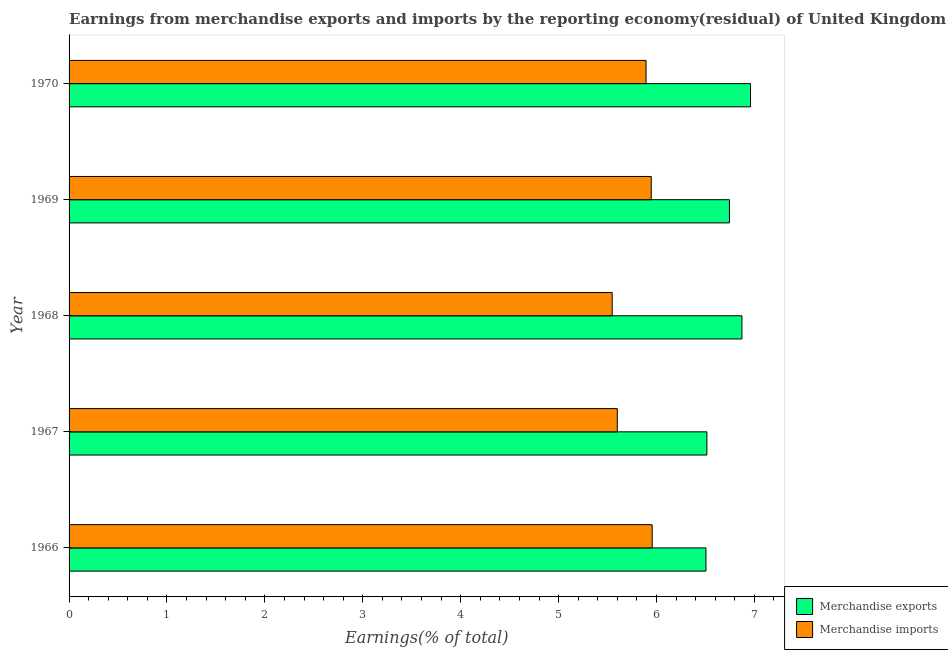Are the number of bars per tick equal to the number of legend labels?
Provide a short and direct response. Yes. How many bars are there on the 3rd tick from the top?
Offer a very short reply. 2. What is the label of the 3rd group of bars from the top?
Make the answer very short. 1968. In how many cases, is the number of bars for a given year not equal to the number of legend labels?
Ensure brevity in your answer.  0. What is the earnings from merchandise imports in 1970?
Provide a succinct answer. 5.89. Across all years, what is the maximum earnings from merchandise exports?
Provide a succinct answer. 6.96. Across all years, what is the minimum earnings from merchandise exports?
Your answer should be compact. 6.51. In which year was the earnings from merchandise imports maximum?
Your answer should be very brief. 1966. In which year was the earnings from merchandise imports minimum?
Offer a very short reply. 1968. What is the total earnings from merchandise imports in the graph?
Give a very brief answer. 28.94. What is the difference between the earnings from merchandise exports in 1966 and that in 1969?
Your response must be concise. -0.24. What is the difference between the earnings from merchandise imports in 1966 and the earnings from merchandise exports in 1967?
Your answer should be compact. -0.56. What is the average earnings from merchandise imports per year?
Your answer should be very brief. 5.79. In the year 1970, what is the difference between the earnings from merchandise imports and earnings from merchandise exports?
Provide a succinct answer. -1.07. What is the difference between the highest and the second highest earnings from merchandise exports?
Provide a short and direct response. 0.09. What is the difference between the highest and the lowest earnings from merchandise imports?
Offer a very short reply. 0.41. Is the sum of the earnings from merchandise imports in 1966 and 1967 greater than the maximum earnings from merchandise exports across all years?
Provide a succinct answer. Yes. What does the 1st bar from the bottom in 1968 represents?
Give a very brief answer. Merchandise exports. How many years are there in the graph?
Give a very brief answer. 5. What is the difference between two consecutive major ticks on the X-axis?
Provide a short and direct response. 1. Are the values on the major ticks of X-axis written in scientific E-notation?
Your response must be concise. No. Where does the legend appear in the graph?
Your answer should be compact. Bottom right. What is the title of the graph?
Provide a short and direct response. Earnings from merchandise exports and imports by the reporting economy(residual) of United Kingdom. What is the label or title of the X-axis?
Provide a succinct answer. Earnings(% of total). What is the label or title of the Y-axis?
Make the answer very short. Year. What is the Earnings(% of total) of Merchandise exports in 1966?
Your response must be concise. 6.51. What is the Earnings(% of total) of Merchandise imports in 1966?
Make the answer very short. 5.96. What is the Earnings(% of total) in Merchandise exports in 1967?
Keep it short and to the point. 6.51. What is the Earnings(% of total) in Merchandise imports in 1967?
Offer a terse response. 5.6. What is the Earnings(% of total) in Merchandise exports in 1968?
Offer a terse response. 6.87. What is the Earnings(% of total) in Merchandise imports in 1968?
Provide a short and direct response. 5.55. What is the Earnings(% of total) in Merchandise exports in 1969?
Offer a terse response. 6.75. What is the Earnings(% of total) in Merchandise imports in 1969?
Give a very brief answer. 5.95. What is the Earnings(% of total) of Merchandise exports in 1970?
Offer a very short reply. 6.96. What is the Earnings(% of total) of Merchandise imports in 1970?
Your response must be concise. 5.89. Across all years, what is the maximum Earnings(% of total) of Merchandise exports?
Ensure brevity in your answer.  6.96. Across all years, what is the maximum Earnings(% of total) in Merchandise imports?
Offer a very short reply. 5.96. Across all years, what is the minimum Earnings(% of total) of Merchandise exports?
Your answer should be very brief. 6.51. Across all years, what is the minimum Earnings(% of total) in Merchandise imports?
Provide a short and direct response. 5.55. What is the total Earnings(% of total) in Merchandise exports in the graph?
Ensure brevity in your answer.  33.6. What is the total Earnings(% of total) in Merchandise imports in the graph?
Keep it short and to the point. 28.94. What is the difference between the Earnings(% of total) in Merchandise exports in 1966 and that in 1967?
Provide a short and direct response. -0.01. What is the difference between the Earnings(% of total) of Merchandise imports in 1966 and that in 1967?
Your answer should be very brief. 0.36. What is the difference between the Earnings(% of total) in Merchandise exports in 1966 and that in 1968?
Your answer should be very brief. -0.37. What is the difference between the Earnings(% of total) of Merchandise imports in 1966 and that in 1968?
Ensure brevity in your answer.  0.41. What is the difference between the Earnings(% of total) of Merchandise exports in 1966 and that in 1969?
Make the answer very short. -0.24. What is the difference between the Earnings(% of total) in Merchandise imports in 1966 and that in 1969?
Offer a terse response. 0.01. What is the difference between the Earnings(% of total) of Merchandise exports in 1966 and that in 1970?
Offer a very short reply. -0.46. What is the difference between the Earnings(% of total) in Merchandise imports in 1966 and that in 1970?
Offer a very short reply. 0.06. What is the difference between the Earnings(% of total) in Merchandise exports in 1967 and that in 1968?
Ensure brevity in your answer.  -0.36. What is the difference between the Earnings(% of total) of Merchandise imports in 1967 and that in 1968?
Give a very brief answer. 0.05. What is the difference between the Earnings(% of total) in Merchandise exports in 1967 and that in 1969?
Your response must be concise. -0.23. What is the difference between the Earnings(% of total) of Merchandise imports in 1967 and that in 1969?
Provide a short and direct response. -0.35. What is the difference between the Earnings(% of total) in Merchandise exports in 1967 and that in 1970?
Your answer should be very brief. -0.45. What is the difference between the Earnings(% of total) in Merchandise imports in 1967 and that in 1970?
Offer a very short reply. -0.29. What is the difference between the Earnings(% of total) of Merchandise exports in 1968 and that in 1969?
Give a very brief answer. 0.13. What is the difference between the Earnings(% of total) of Merchandise imports in 1968 and that in 1969?
Your answer should be compact. -0.4. What is the difference between the Earnings(% of total) of Merchandise exports in 1968 and that in 1970?
Your answer should be compact. -0.09. What is the difference between the Earnings(% of total) in Merchandise imports in 1968 and that in 1970?
Offer a very short reply. -0.35. What is the difference between the Earnings(% of total) of Merchandise exports in 1969 and that in 1970?
Make the answer very short. -0.22. What is the difference between the Earnings(% of total) in Merchandise imports in 1969 and that in 1970?
Your answer should be very brief. 0.05. What is the difference between the Earnings(% of total) in Merchandise exports in 1966 and the Earnings(% of total) in Merchandise imports in 1967?
Offer a very short reply. 0.91. What is the difference between the Earnings(% of total) in Merchandise exports in 1966 and the Earnings(% of total) in Merchandise imports in 1968?
Offer a terse response. 0.96. What is the difference between the Earnings(% of total) of Merchandise exports in 1966 and the Earnings(% of total) of Merchandise imports in 1969?
Provide a short and direct response. 0.56. What is the difference between the Earnings(% of total) in Merchandise exports in 1966 and the Earnings(% of total) in Merchandise imports in 1970?
Keep it short and to the point. 0.61. What is the difference between the Earnings(% of total) in Merchandise exports in 1967 and the Earnings(% of total) in Merchandise imports in 1968?
Ensure brevity in your answer.  0.97. What is the difference between the Earnings(% of total) in Merchandise exports in 1967 and the Earnings(% of total) in Merchandise imports in 1969?
Provide a succinct answer. 0.57. What is the difference between the Earnings(% of total) in Merchandise exports in 1967 and the Earnings(% of total) in Merchandise imports in 1970?
Ensure brevity in your answer.  0.62. What is the difference between the Earnings(% of total) of Merchandise exports in 1968 and the Earnings(% of total) of Merchandise imports in 1969?
Provide a succinct answer. 0.93. What is the difference between the Earnings(% of total) of Merchandise exports in 1968 and the Earnings(% of total) of Merchandise imports in 1970?
Keep it short and to the point. 0.98. What is the difference between the Earnings(% of total) of Merchandise exports in 1969 and the Earnings(% of total) of Merchandise imports in 1970?
Your answer should be very brief. 0.85. What is the average Earnings(% of total) of Merchandise exports per year?
Keep it short and to the point. 6.72. What is the average Earnings(% of total) in Merchandise imports per year?
Keep it short and to the point. 5.79. In the year 1966, what is the difference between the Earnings(% of total) in Merchandise exports and Earnings(% of total) in Merchandise imports?
Provide a succinct answer. 0.55. In the year 1967, what is the difference between the Earnings(% of total) in Merchandise exports and Earnings(% of total) in Merchandise imports?
Provide a succinct answer. 0.91. In the year 1968, what is the difference between the Earnings(% of total) of Merchandise exports and Earnings(% of total) of Merchandise imports?
Provide a succinct answer. 1.33. In the year 1969, what is the difference between the Earnings(% of total) of Merchandise exports and Earnings(% of total) of Merchandise imports?
Make the answer very short. 0.8. In the year 1970, what is the difference between the Earnings(% of total) of Merchandise exports and Earnings(% of total) of Merchandise imports?
Offer a terse response. 1.07. What is the ratio of the Earnings(% of total) of Merchandise imports in 1966 to that in 1967?
Give a very brief answer. 1.06. What is the ratio of the Earnings(% of total) of Merchandise exports in 1966 to that in 1968?
Your answer should be compact. 0.95. What is the ratio of the Earnings(% of total) of Merchandise imports in 1966 to that in 1968?
Provide a succinct answer. 1.07. What is the ratio of the Earnings(% of total) in Merchandise exports in 1966 to that in 1969?
Your answer should be very brief. 0.96. What is the ratio of the Earnings(% of total) in Merchandise imports in 1966 to that in 1969?
Keep it short and to the point. 1. What is the ratio of the Earnings(% of total) of Merchandise exports in 1966 to that in 1970?
Provide a short and direct response. 0.93. What is the ratio of the Earnings(% of total) in Merchandise imports in 1966 to that in 1970?
Your response must be concise. 1.01. What is the ratio of the Earnings(% of total) in Merchandise exports in 1967 to that in 1968?
Offer a terse response. 0.95. What is the ratio of the Earnings(% of total) in Merchandise imports in 1967 to that in 1968?
Provide a succinct answer. 1.01. What is the ratio of the Earnings(% of total) of Merchandise exports in 1967 to that in 1969?
Your response must be concise. 0.97. What is the ratio of the Earnings(% of total) in Merchandise imports in 1967 to that in 1969?
Offer a very short reply. 0.94. What is the ratio of the Earnings(% of total) in Merchandise exports in 1967 to that in 1970?
Your answer should be compact. 0.94. What is the ratio of the Earnings(% of total) of Merchandise imports in 1967 to that in 1970?
Provide a short and direct response. 0.95. What is the ratio of the Earnings(% of total) of Merchandise exports in 1968 to that in 1969?
Ensure brevity in your answer.  1.02. What is the ratio of the Earnings(% of total) of Merchandise imports in 1968 to that in 1969?
Keep it short and to the point. 0.93. What is the ratio of the Earnings(% of total) in Merchandise exports in 1968 to that in 1970?
Your response must be concise. 0.99. What is the ratio of the Earnings(% of total) in Merchandise imports in 1968 to that in 1970?
Your answer should be very brief. 0.94. What is the ratio of the Earnings(% of total) of Merchandise exports in 1969 to that in 1970?
Keep it short and to the point. 0.97. What is the ratio of the Earnings(% of total) in Merchandise imports in 1969 to that in 1970?
Make the answer very short. 1.01. What is the difference between the highest and the second highest Earnings(% of total) in Merchandise exports?
Offer a terse response. 0.09. What is the difference between the highest and the second highest Earnings(% of total) in Merchandise imports?
Give a very brief answer. 0.01. What is the difference between the highest and the lowest Earnings(% of total) of Merchandise exports?
Provide a succinct answer. 0.46. What is the difference between the highest and the lowest Earnings(% of total) of Merchandise imports?
Offer a very short reply. 0.41. 